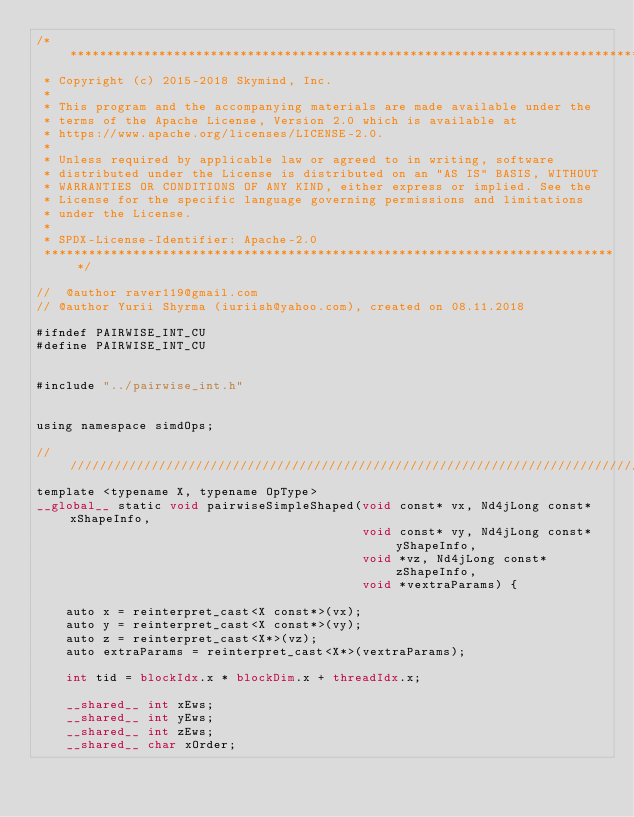<code> <loc_0><loc_0><loc_500><loc_500><_Cuda_>/*******************************************************************************
 * Copyright (c) 2015-2018 Skymind, Inc.
 *
 * This program and the accompanying materials are made available under the
 * terms of the Apache License, Version 2.0 which is available at
 * https://www.apache.org/licenses/LICENSE-2.0.
 *
 * Unless required by applicable law or agreed to in writing, software
 * distributed under the License is distributed on an "AS IS" BASIS, WITHOUT
 * WARRANTIES OR CONDITIONS OF ANY KIND, either express or implied. See the
 * License for the specific language governing permissions and limitations
 * under the License.
 *
 * SPDX-License-Identifier: Apache-2.0
 ******************************************************************************/

//  @author raver119@gmail.com
// @author Yurii Shyrma (iuriish@yahoo.com), created on 08.11.2018

#ifndef PAIRWISE_INT_CU
#define PAIRWISE_INT_CU


#include "../pairwise_int.h"


using namespace simdOps;

////////////////////////////////////////////////////////////////////////////////
template <typename X, typename OpType>
__global__ static void pairwiseSimpleShaped(void const* vx, Nd4jLong const* xShapeInfo,
											void const* vy, Nd4jLong const* yShapeInfo,
											void *vz, Nd4jLong const* zShapeInfo,
											void *vextraParams) {

	auto x = reinterpret_cast<X const*>(vx);
	auto y = reinterpret_cast<X const*>(vy);
	auto z = reinterpret_cast<X*>(vz);
	auto extraParams = reinterpret_cast<X*>(vextraParams);

	int tid = blockIdx.x * blockDim.x + threadIdx.x;

	__shared__ int xEws;
	__shared__ int yEws;
	__shared__ int zEws;
	__shared__ char xOrder;</code> 